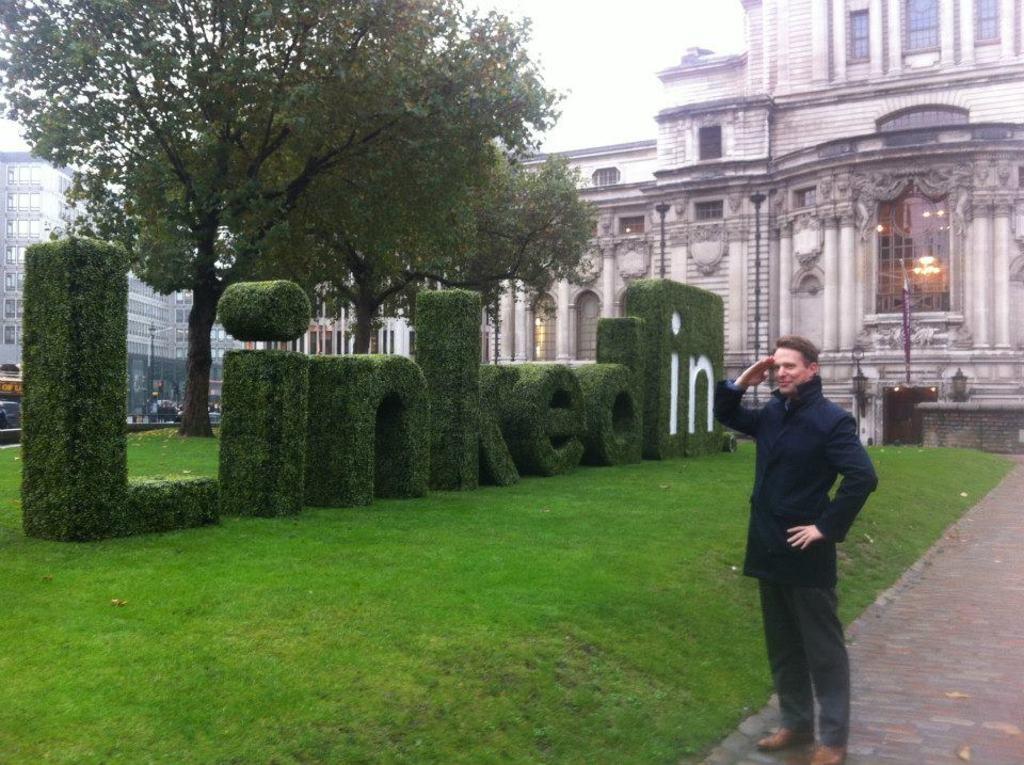How would you summarize this image in a sentence or two? In the middle of the image a man is standing. Behind him there is grass and trees and buildings. At the top of the image there is sky. 